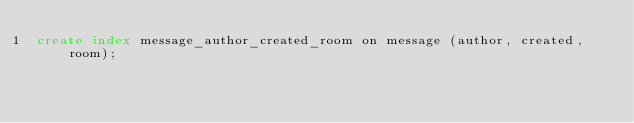<code> <loc_0><loc_0><loc_500><loc_500><_SQL_>create index message_author_created_room on message (author, created, room);
</code> 